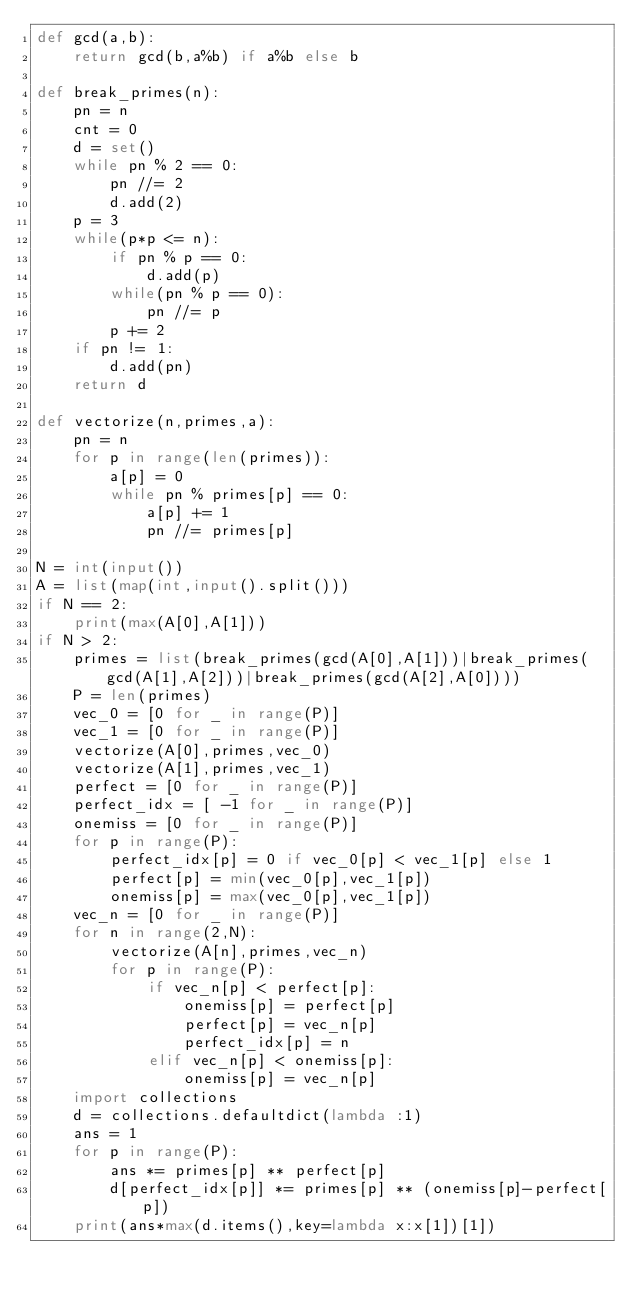Convert code to text. <code><loc_0><loc_0><loc_500><loc_500><_Python_>def gcd(a,b):
    return gcd(b,a%b) if a%b else b

def break_primes(n):
    pn = n
    cnt = 0
    d = set()
    while pn % 2 == 0:
        pn //= 2
        d.add(2)
    p = 3
    while(p*p <= n):
        if pn % p == 0:
            d.add(p)
        while(pn % p == 0):
            pn //= p
        p += 2
    if pn != 1:
        d.add(pn)
    return d

def vectorize(n,primes,a):
    pn = n
    for p in range(len(primes)):
        a[p] = 0
        while pn % primes[p] == 0:
            a[p] += 1
            pn //= primes[p]

N = int(input())
A = list(map(int,input().split()))
if N == 2:
    print(max(A[0],A[1]))
if N > 2:
    primes = list(break_primes(gcd(A[0],A[1]))|break_primes(gcd(A[1],A[2]))|break_primes(gcd(A[2],A[0])))
    P = len(primes)
    vec_0 = [0 for _ in range(P)]
    vec_1 = [0 for _ in range(P)]
    vectorize(A[0],primes,vec_0)
    vectorize(A[1],primes,vec_1)
    perfect = [0 for _ in range(P)]
    perfect_idx = [ -1 for _ in range(P)]
    onemiss = [0 for _ in range(P)]
    for p in range(P):
        perfect_idx[p] = 0 if vec_0[p] < vec_1[p] else 1
        perfect[p] = min(vec_0[p],vec_1[p])
        onemiss[p] = max(vec_0[p],vec_1[p])
    vec_n = [0 for _ in range(P)]
    for n in range(2,N):
        vectorize(A[n],primes,vec_n)
        for p in range(P):
            if vec_n[p] < perfect[p]:
                onemiss[p] = perfect[p]
                perfect[p] = vec_n[p]
                perfect_idx[p] = n
            elif vec_n[p] < onemiss[p]:
                onemiss[p] = vec_n[p]
    import collections
    d = collections.defaultdict(lambda :1)
    ans = 1
    for p in range(P):
        ans *= primes[p] ** perfect[p]
        d[perfect_idx[p]] *= primes[p] ** (onemiss[p]-perfect[p])
    print(ans*max(d.items(),key=lambda x:x[1])[1])</code> 